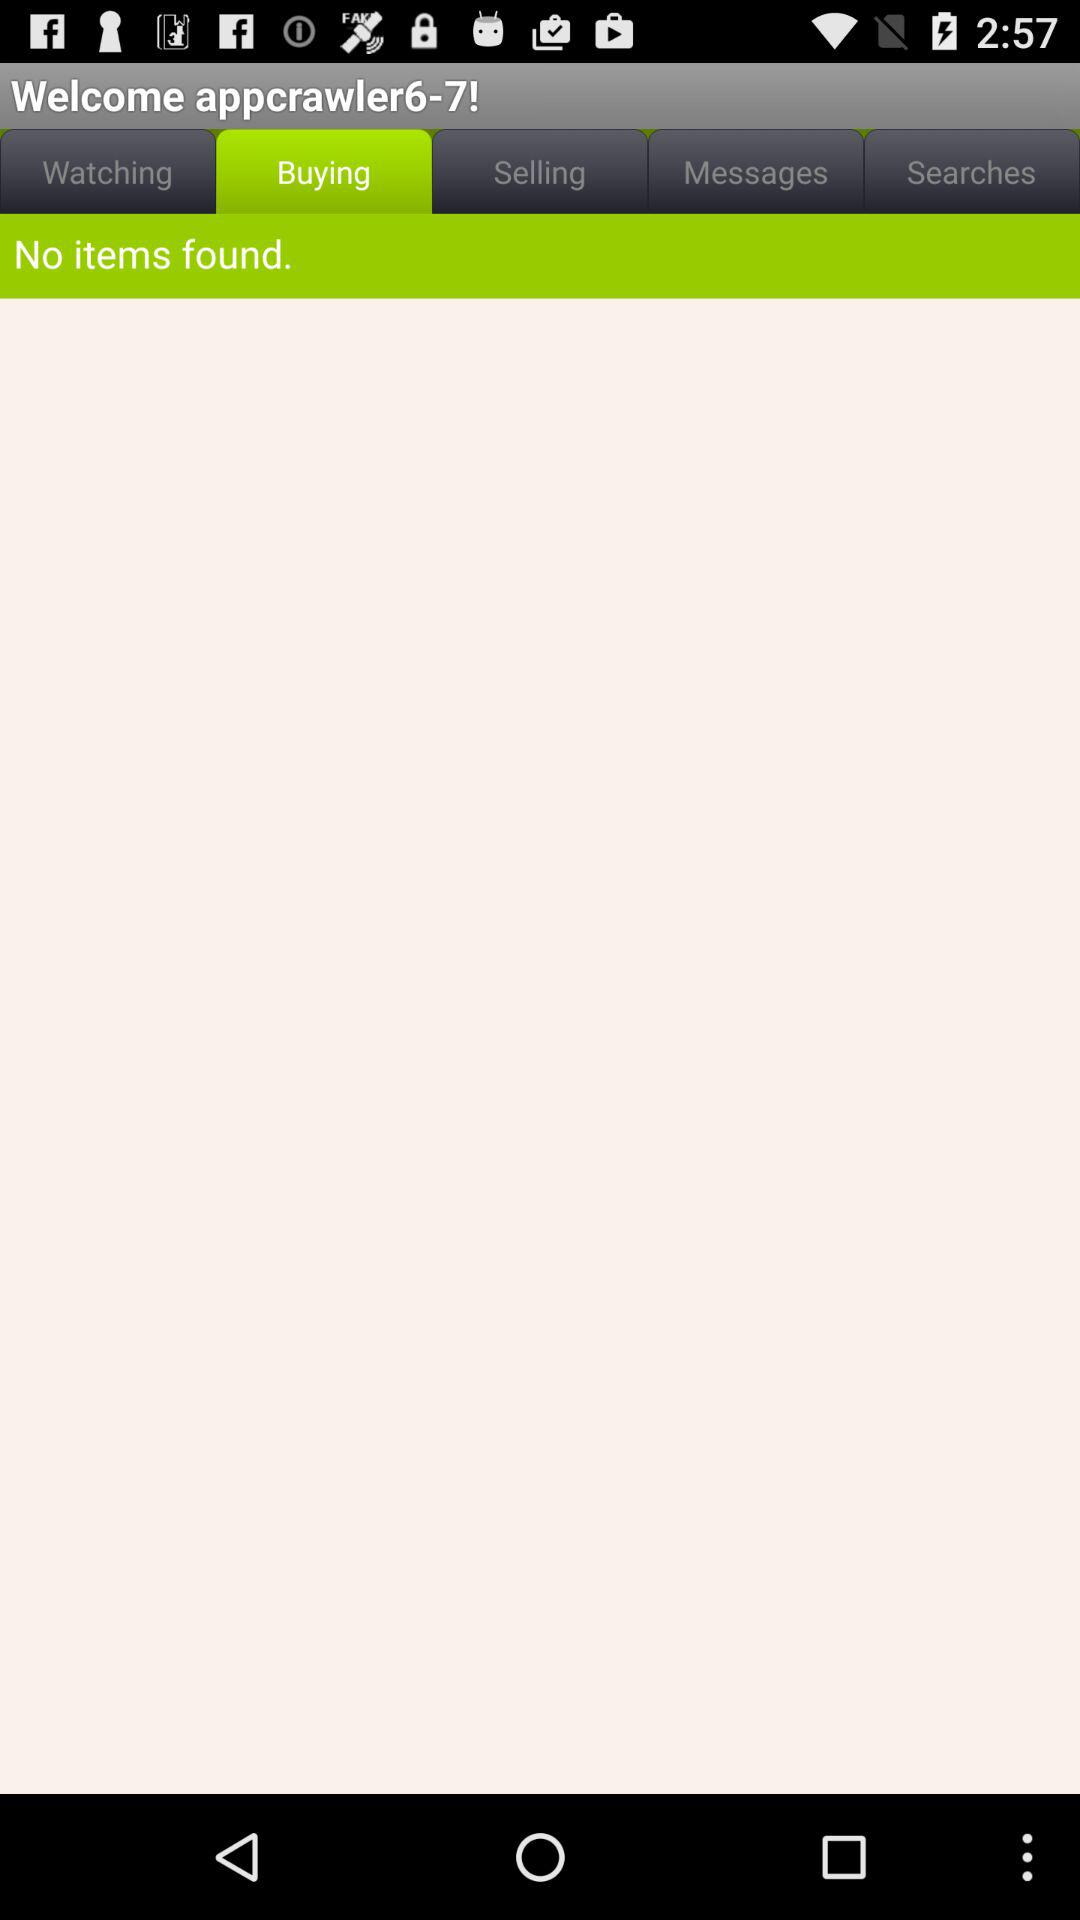What is the username? The username is "appcrawler6-7!". 